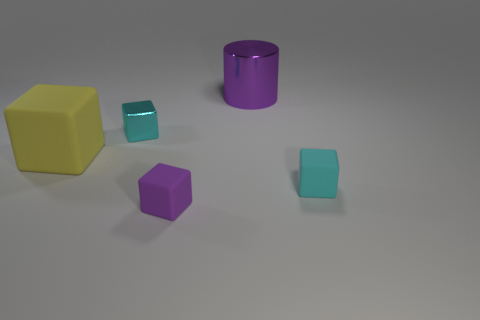What is the size of the other thing that is the same color as the tiny metal object?
Make the answer very short. Small. What is the shape of the rubber thing that is the same color as the shiny cylinder?
Provide a short and direct response. Cube. How many other objects are there of the same size as the yellow rubber block?
Ensure brevity in your answer.  1. Do the metal cylinder and the purple thing that is in front of the large purple metal object have the same size?
Ensure brevity in your answer.  No. What shape is the big object that is behind the tiny metal cube behind the tiny matte cube that is on the right side of the large purple shiny thing?
Offer a terse response. Cylinder. Are there fewer shiny cylinders than tiny cyan things?
Ensure brevity in your answer.  Yes. Are there any small blocks right of the purple rubber cube?
Your answer should be very brief. Yes. What shape is the thing that is both on the right side of the purple rubber thing and behind the large matte thing?
Ensure brevity in your answer.  Cylinder. Is there a tiny purple matte thing that has the same shape as the large matte thing?
Your answer should be compact. Yes. Is the size of the cyan object that is behind the large yellow rubber object the same as the shiny object that is on the right side of the shiny block?
Your response must be concise. No. 